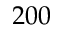Convert formula to latex. <formula><loc_0><loc_0><loc_500><loc_500>2 0 0</formula> 